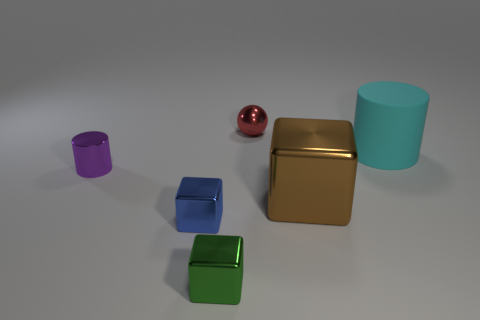There is another large shiny thing that is the same shape as the blue metal object; what color is it?
Provide a succinct answer. Brown. The cylinder behind the purple metal object that is to the left of the big matte cylinder is made of what material?
Provide a succinct answer. Rubber. Does the big thing that is behind the purple cylinder have the same shape as the metal thing that is behind the tiny purple shiny cylinder?
Provide a succinct answer. No. There is a cube that is both left of the shiny ball and behind the tiny green metal thing; how big is it?
Your answer should be compact. Small. Is the small red sphere behind the cyan rubber cylinder made of the same material as the blue thing?
Provide a short and direct response. Yes. Are there any other things that have the same size as the brown metallic block?
Your answer should be compact. Yes. Are there fewer small shiny objects right of the tiny purple cylinder than cyan things on the left side of the blue cube?
Give a very brief answer. No. Is there anything else that has the same shape as the red shiny thing?
Keep it short and to the point. No. What number of small blue metal objects are in front of the green block that is left of the cylinder that is right of the tiny metal ball?
Offer a very short reply. 0. What number of tiny red objects are left of the large matte cylinder?
Ensure brevity in your answer.  1. 